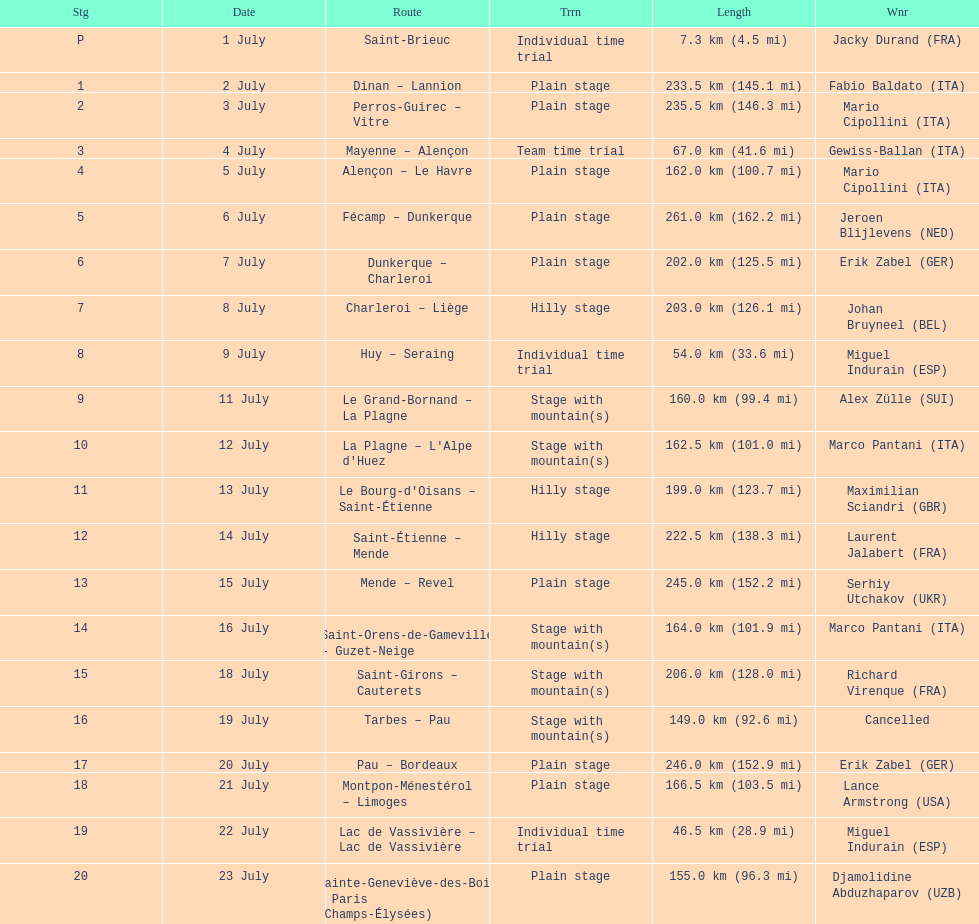How much longer is the 20th tour de france stage than the 19th? 108.5 km. 